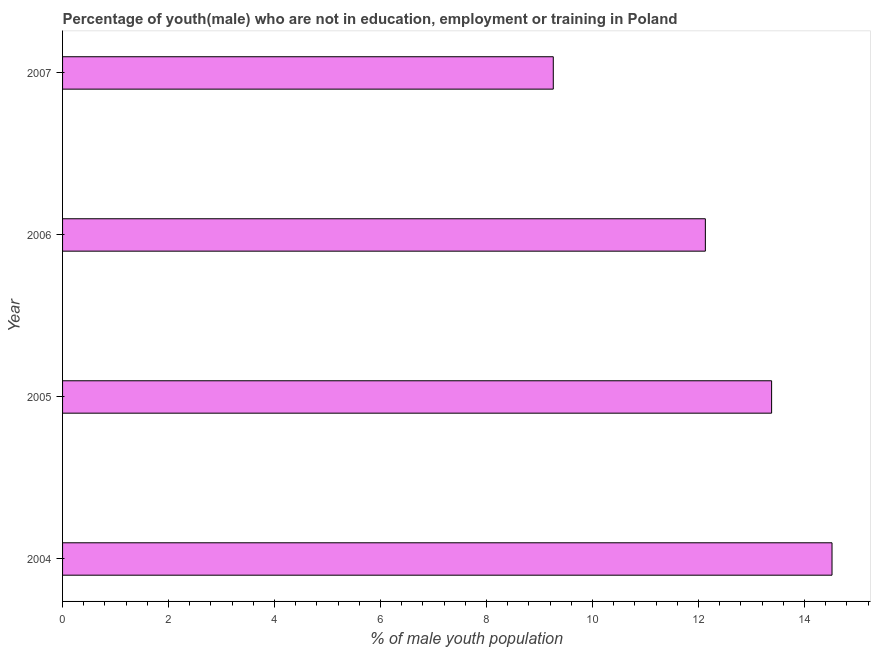What is the title of the graph?
Keep it short and to the point. Percentage of youth(male) who are not in education, employment or training in Poland. What is the label or title of the X-axis?
Ensure brevity in your answer.  % of male youth population. What is the label or title of the Y-axis?
Offer a terse response. Year. What is the unemployed male youth population in 2006?
Make the answer very short. 12.13. Across all years, what is the maximum unemployed male youth population?
Your response must be concise. 14.52. Across all years, what is the minimum unemployed male youth population?
Your answer should be very brief. 9.26. In which year was the unemployed male youth population maximum?
Provide a succinct answer. 2004. What is the sum of the unemployed male youth population?
Keep it short and to the point. 49.29. What is the difference between the unemployed male youth population in 2006 and 2007?
Provide a succinct answer. 2.87. What is the average unemployed male youth population per year?
Your answer should be compact. 12.32. What is the median unemployed male youth population?
Offer a very short reply. 12.76. Do a majority of the years between 2007 and 2005 (inclusive) have unemployed male youth population greater than 4.4 %?
Give a very brief answer. Yes. What is the ratio of the unemployed male youth population in 2005 to that in 2007?
Your response must be concise. 1.45. Is the unemployed male youth population in 2004 less than that in 2007?
Provide a succinct answer. No. Is the difference between the unemployed male youth population in 2005 and 2007 greater than the difference between any two years?
Offer a terse response. No. What is the difference between the highest and the second highest unemployed male youth population?
Give a very brief answer. 1.14. What is the difference between the highest and the lowest unemployed male youth population?
Give a very brief answer. 5.26. In how many years, is the unemployed male youth population greater than the average unemployed male youth population taken over all years?
Provide a succinct answer. 2. How many bars are there?
Your answer should be compact. 4. Are all the bars in the graph horizontal?
Make the answer very short. Yes. What is the difference between two consecutive major ticks on the X-axis?
Keep it short and to the point. 2. Are the values on the major ticks of X-axis written in scientific E-notation?
Ensure brevity in your answer.  No. What is the % of male youth population in 2004?
Ensure brevity in your answer.  14.52. What is the % of male youth population in 2005?
Your answer should be compact. 13.38. What is the % of male youth population of 2006?
Your answer should be compact. 12.13. What is the % of male youth population of 2007?
Keep it short and to the point. 9.26. What is the difference between the % of male youth population in 2004 and 2005?
Ensure brevity in your answer.  1.14. What is the difference between the % of male youth population in 2004 and 2006?
Offer a very short reply. 2.39. What is the difference between the % of male youth population in 2004 and 2007?
Your response must be concise. 5.26. What is the difference between the % of male youth population in 2005 and 2006?
Your answer should be very brief. 1.25. What is the difference between the % of male youth population in 2005 and 2007?
Your answer should be compact. 4.12. What is the difference between the % of male youth population in 2006 and 2007?
Provide a succinct answer. 2.87. What is the ratio of the % of male youth population in 2004 to that in 2005?
Your answer should be compact. 1.08. What is the ratio of the % of male youth population in 2004 to that in 2006?
Offer a very short reply. 1.2. What is the ratio of the % of male youth population in 2004 to that in 2007?
Provide a succinct answer. 1.57. What is the ratio of the % of male youth population in 2005 to that in 2006?
Make the answer very short. 1.1. What is the ratio of the % of male youth population in 2005 to that in 2007?
Ensure brevity in your answer.  1.45. What is the ratio of the % of male youth population in 2006 to that in 2007?
Your response must be concise. 1.31. 